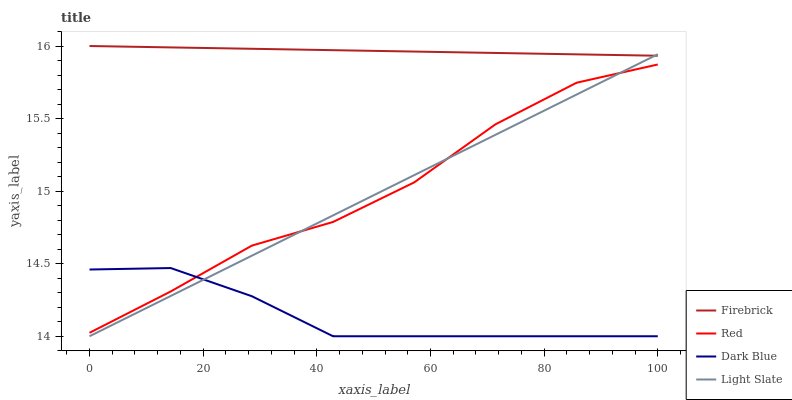Does Firebrick have the minimum area under the curve?
Answer yes or no. No. Does Dark Blue have the maximum area under the curve?
Answer yes or no. No. Is Dark Blue the smoothest?
Answer yes or no. No. Is Dark Blue the roughest?
Answer yes or no. No. Does Firebrick have the lowest value?
Answer yes or no. No. Does Dark Blue have the highest value?
Answer yes or no. No. Is Red less than Firebrick?
Answer yes or no. Yes. Is Firebrick greater than Dark Blue?
Answer yes or no. Yes. Does Red intersect Firebrick?
Answer yes or no. No. 